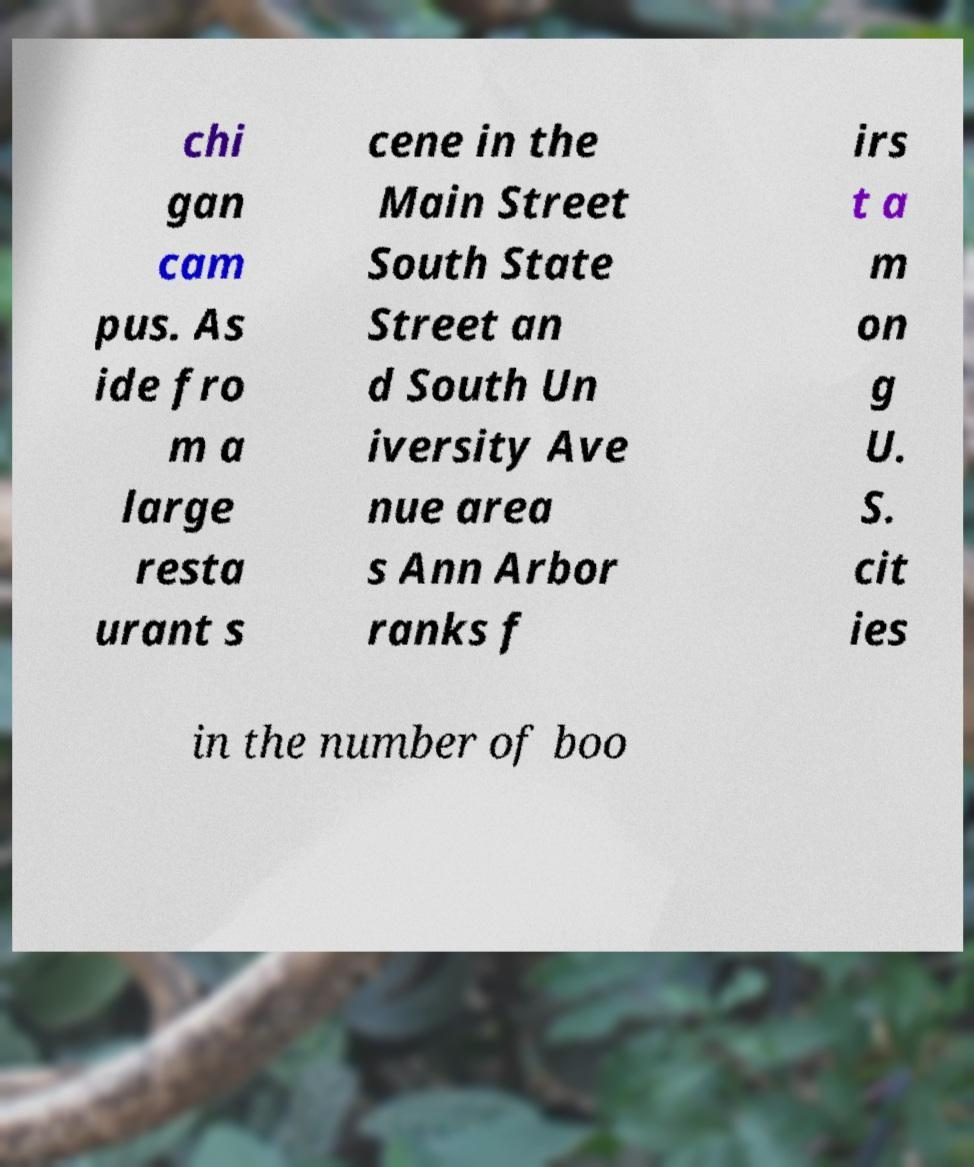What messages or text are displayed in this image? I need them in a readable, typed format. chi gan cam pus. As ide fro m a large resta urant s cene in the Main Street South State Street an d South Un iversity Ave nue area s Ann Arbor ranks f irs t a m on g U. S. cit ies in the number of boo 